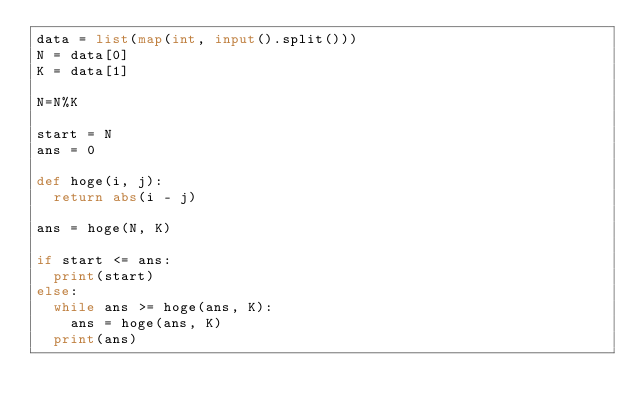Convert code to text. <code><loc_0><loc_0><loc_500><loc_500><_Python_>data = list(map(int, input().split()))
N = data[0]
K = data[1]

N=N%K

start = N
ans = 0

def hoge(i, j):
  return abs(i - j)

ans = hoge(N, K)

if start <= ans:
  print(start)
else:
  while ans >= hoge(ans, K):
    ans = hoge(ans, K)
  print(ans)</code> 